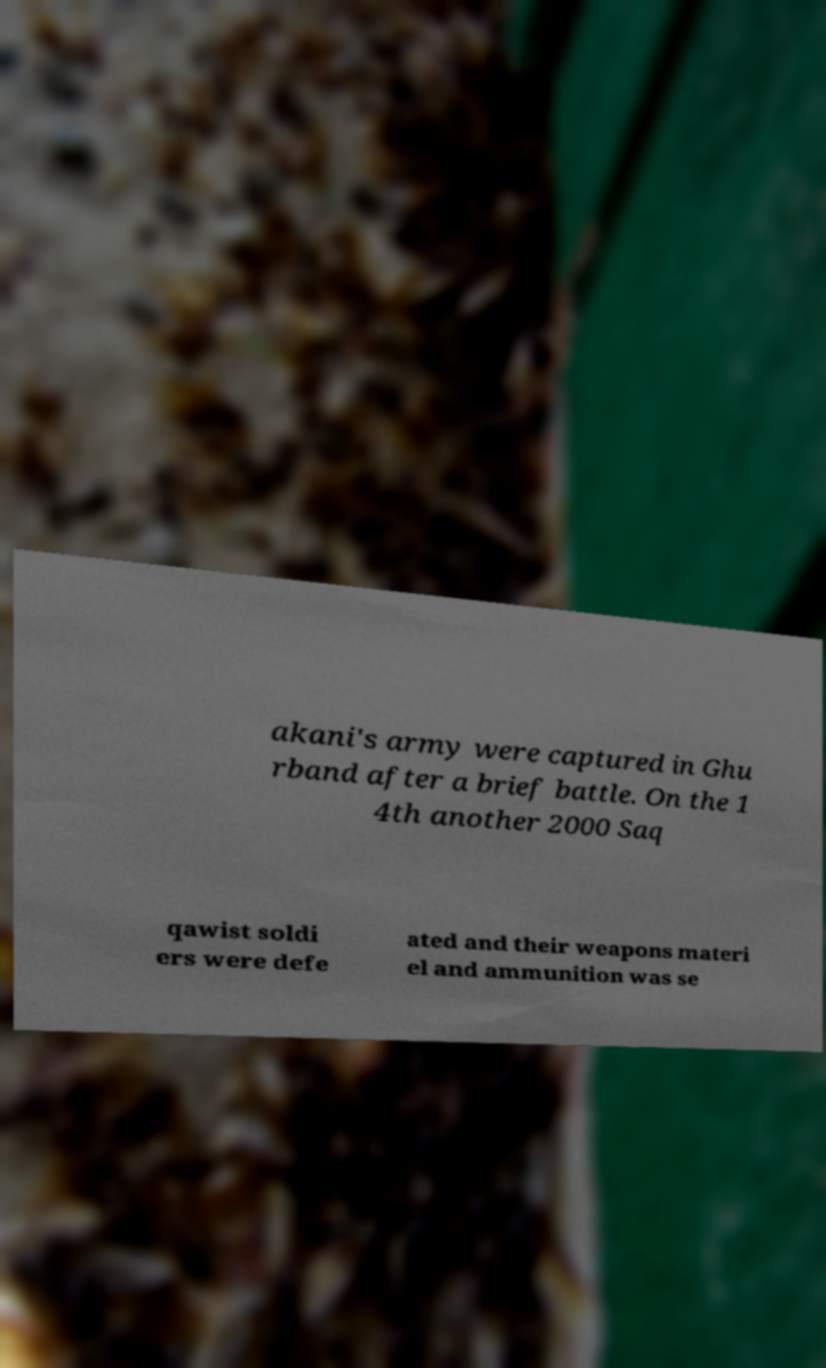Can you read and provide the text displayed in the image?This photo seems to have some interesting text. Can you extract and type it out for me? akani's army were captured in Ghu rband after a brief battle. On the 1 4th another 2000 Saq qawist soldi ers were defe ated and their weapons materi el and ammunition was se 